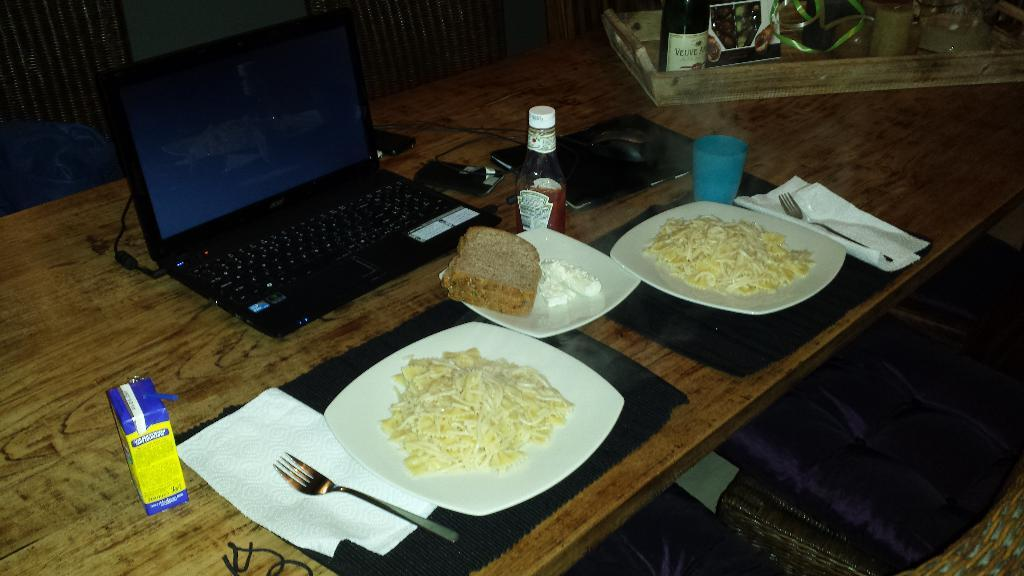What object can be seen in the image that is typically used for storage? There is a box in the image that is typically used for storage. What item in the image is commonly used for cleaning or wiping? There is no item in the image that is commonly used for cleaning or wiping. What type of food is visible in the image? There are noodles and brown bread on a plate in the image. What beverage container is present in the image? There is a cup and a bottle in the image. What electronic device is visible in the image? There is a laptop and a phone in the image. What items are placed in a tray in the image? There are items in a tray in the image, but the specific items are not mentioned in the provided facts. What type of spring is visible in the image? There is no spring present in the image. What knowledge can be gained from the image? The image does not convey any specific knowledge or information. 